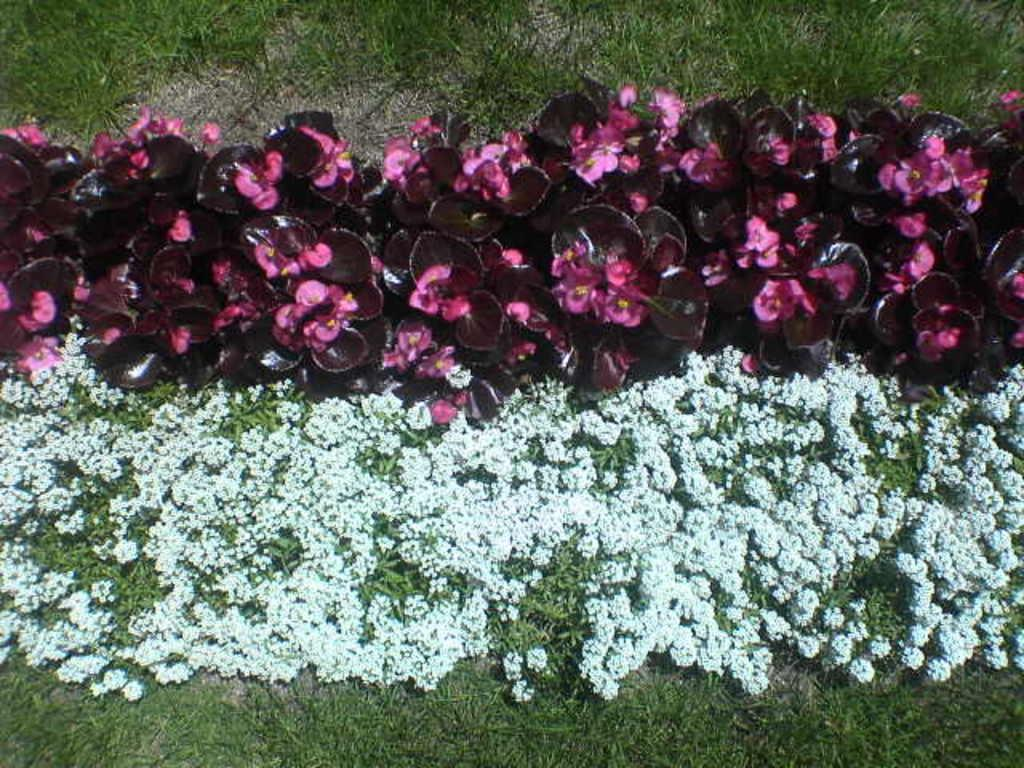What type of vegetation can be seen in the image? There are plants and flowers in the image. What is covering the ground in the image? There is grass on the ground in the image. What word is being used to describe the range of colors in the image? There is no mention of a range of colors or a specific word to describe it in the image. 